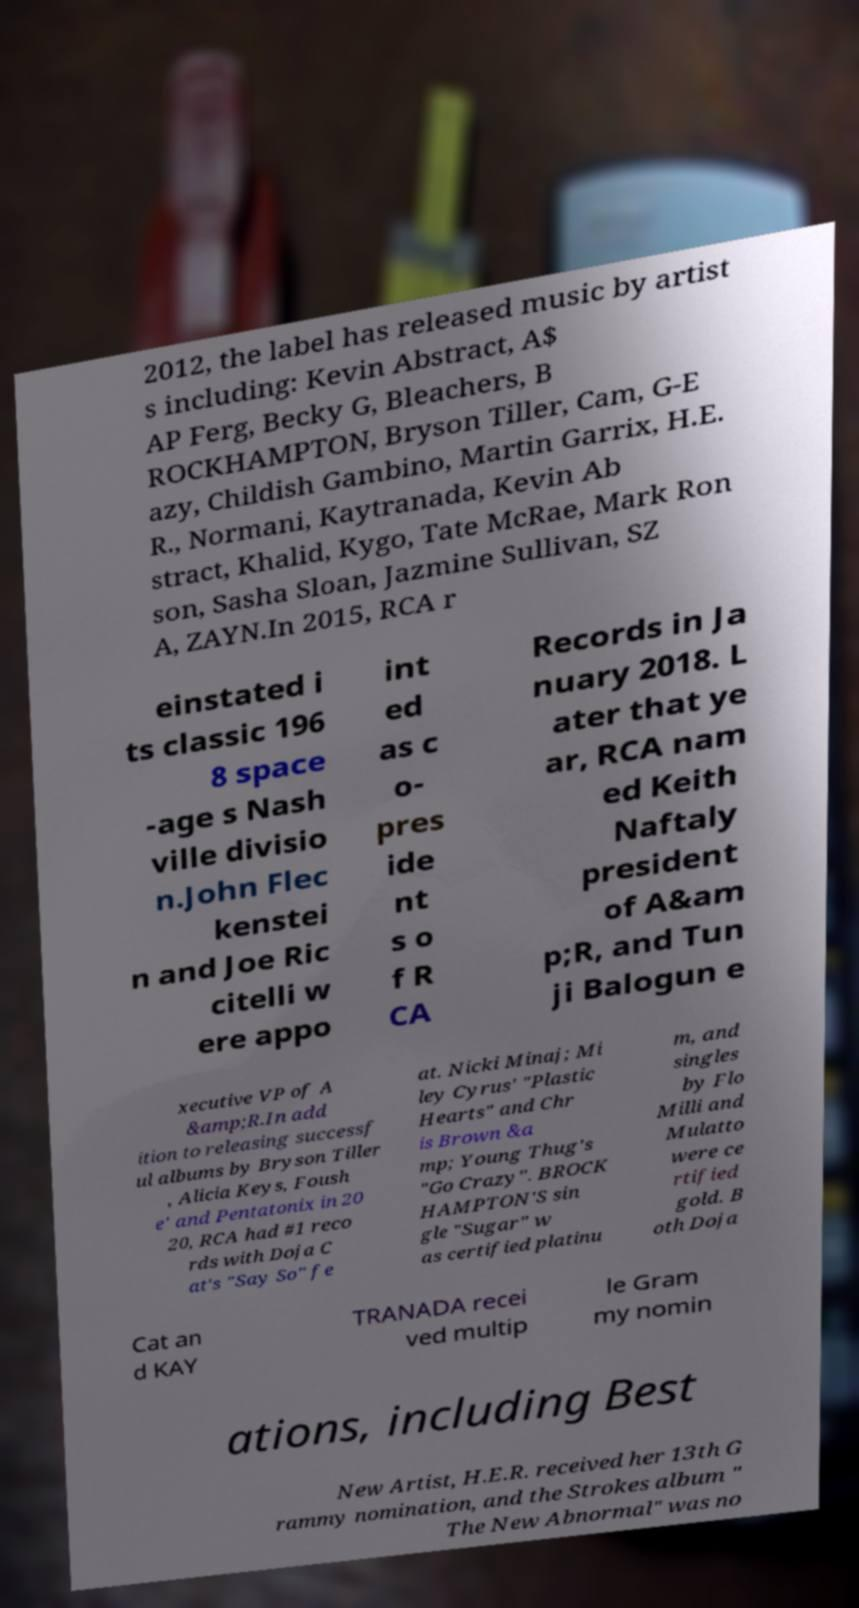There's text embedded in this image that I need extracted. Can you transcribe it verbatim? 2012, the label has released music by artist s including: Kevin Abstract, A$ AP Ferg, Becky G, Bleachers, B ROCKHAMPTON, Bryson Tiller, Cam, G-E azy, Childish Gambino, Martin Garrix, H.E. R., Normani, Kaytranada, Kevin Ab stract, Khalid, Kygo, Tate McRae, Mark Ron son, Sasha Sloan, Jazmine Sullivan, SZ A, ZAYN.In 2015, RCA r einstated i ts classic 196 8 space -age s Nash ville divisio n.John Flec kenstei n and Joe Ric citelli w ere appo int ed as c o- pres ide nt s o f R CA Records in Ja nuary 2018. L ater that ye ar, RCA nam ed Keith Naftaly president of A&am p;R, and Tun ji Balogun e xecutive VP of A &amp;R.In add ition to releasing successf ul albums by Bryson Tiller , Alicia Keys, Foush e' and Pentatonix in 20 20, RCA had #1 reco rds with Doja C at's "Say So" fe at. Nicki Minaj; Mi ley Cyrus' "Plastic Hearts" and Chr is Brown &a mp; Young Thug's "Go Crazy". BROCK HAMPTON'S sin gle "Sugar" w as certified platinu m, and singles by Flo Milli and Mulatto were ce rtified gold. B oth Doja Cat an d KAY TRANADA recei ved multip le Gram my nomin ations, including Best New Artist, H.E.R. received her 13th G rammy nomination, and the Strokes album " The New Abnormal" was no 